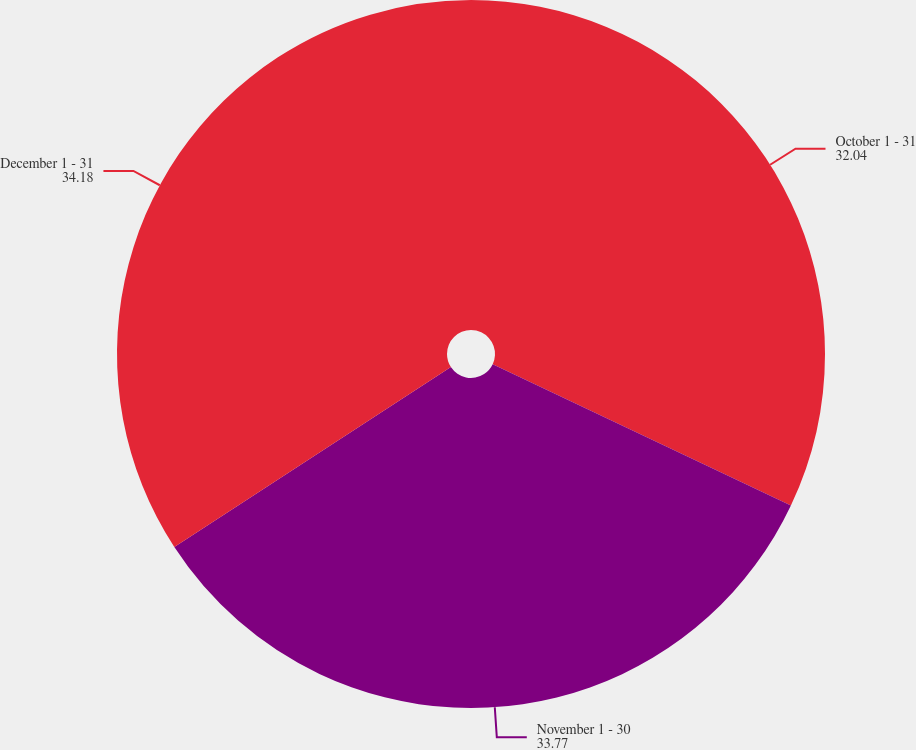Convert chart. <chart><loc_0><loc_0><loc_500><loc_500><pie_chart><fcel>October 1 - 31<fcel>November 1 - 30<fcel>December 1 - 31<nl><fcel>32.04%<fcel>33.77%<fcel>34.18%<nl></chart> 